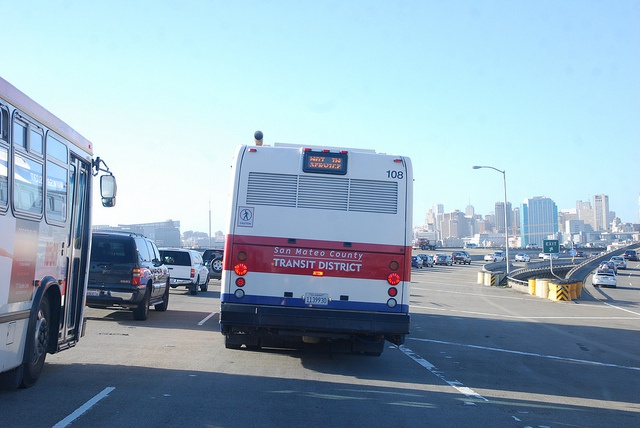Describe the objects in this image and their specific colors. I can see bus in lightblue, darkgray, black, and navy tones, bus in lightblue, darkgray, and black tones, car in lightblue, navy, black, darkblue, and gray tones, car in lightblue, darkgray, gray, and lightgray tones, and car in lightblue, darkgray, and navy tones in this image. 